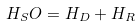<formula> <loc_0><loc_0><loc_500><loc_500>H _ { S } O = H _ { D } + H _ { R }</formula> 